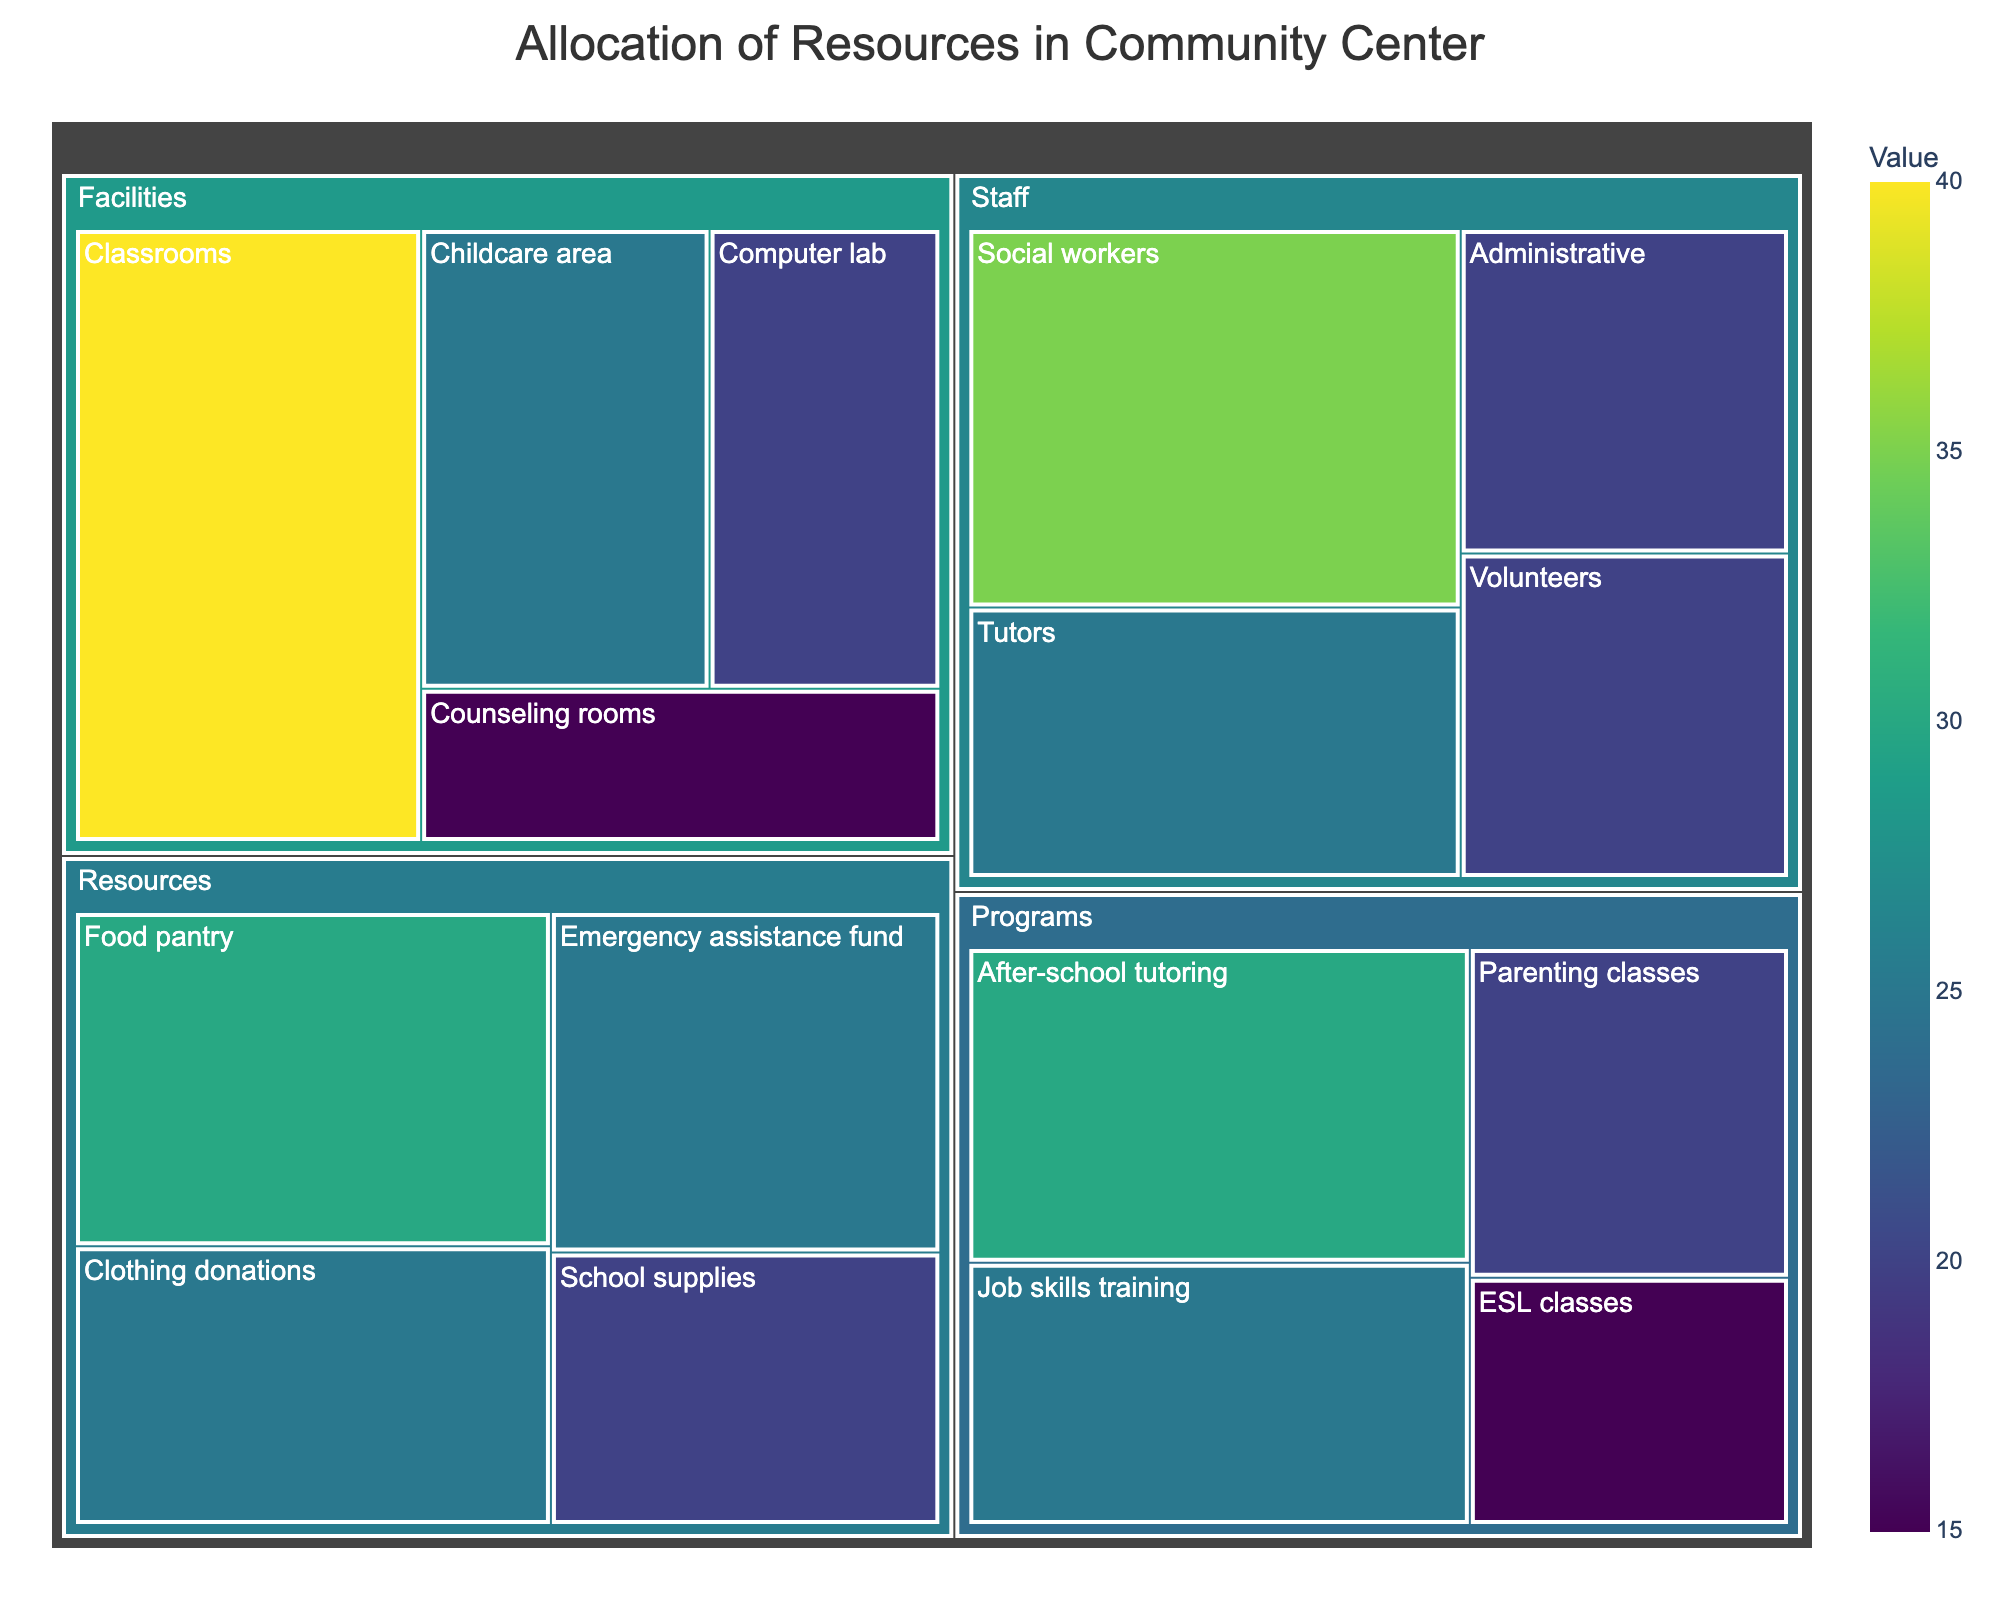What is the title of the treemap? The title of the treemap is displayed at the top, outlining the main subject of the visual representation.
Answer: Allocation of Resources in Community Center Which category has the highest allocation value, and what is the value? You can check the sizes of the sections to see which category occupies the largest area and then note its allocation value. The 'Facilities' category has the largest area.
Answer: Facilities, 100 How many subcategories are under the Facilities category? Look for the number of subdivided sections within the 'Facilities' category to count the unique subcategories.
Answer: 4 Compare the value allocated to 'Social workers' and 'Volunteers'. Which one has a higher value and by how much? Find and compare the values for 'Social workers' and 'Volunteers'. 'Social workers' has a value of 35, and 'Volunteers' has a value of 20. The difference is 35 - 20.
Answer: Social workers by 15 What is the total allocation value for all resources under the 'Programs' category? Add the allocation values for all the subcategories within 'Programs': 30 (After-school tutoring) + 20 (Parenting classes) + 25 (Job skills training) + 15 (ESL classes).
Answer: 90 Which subcategory has the smallest allocation value and what is that value? Find the smallest section on the treemap and check its value. The 'ESL classes' and 'Counseling rooms' both share this position.
Answer: ESL classes and Counseling rooms, 15 What is the average value of the subcategories under 'Resources'? Sum the values of the subcategories under 'Resources' and divide by the number of subcategories: (30 + 25 + 20 + 25) / 4.
Answer: 25 Which category has the closest allocation value to 'Staff'? Check the allocation values for each category and compare them to the value for 'Staff' (100). The 'Facilities' category is closest with a value of 100.
Answer: Facilities How is the distribution of values within the 'Staff' category compared to 'Resources'? Examine the values for the subcategories within 'Staff' (35, 25, 20, 20) and those within 'Resources' (30, 25, 20, 25). Notice that 'Staff' has a higher peak value but also some lower values, whereas 'Resources' are more evenly distributed.
Answer: Staff has more variability, Resources have more uniform distribution 